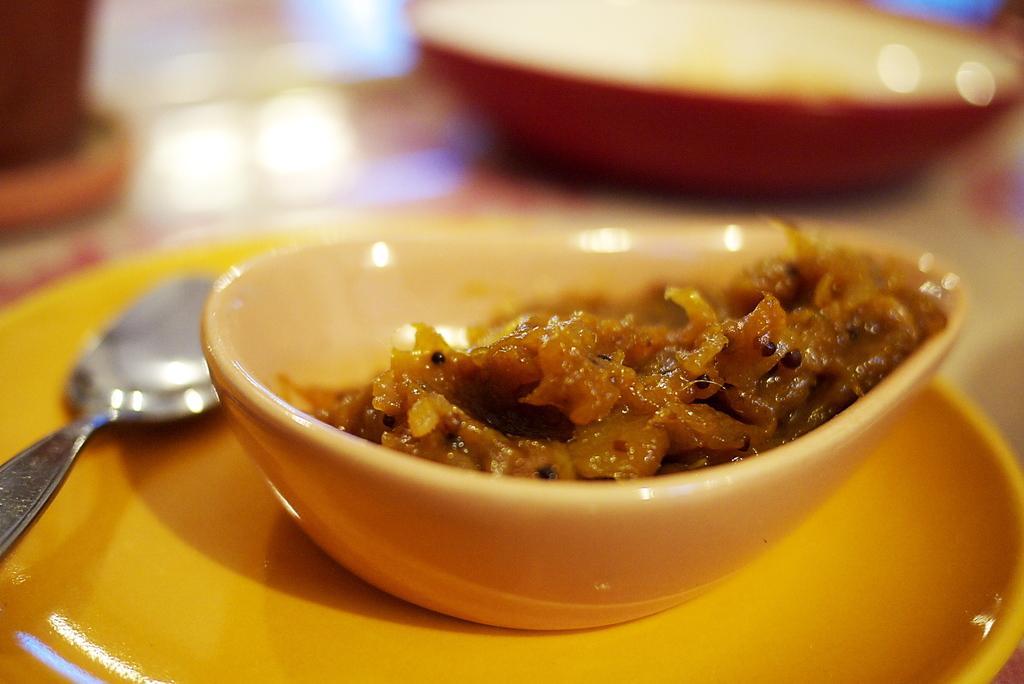How would you summarize this image in a sentence or two? In this picture I can see a plate and food in the bowl and I can see a spoon on the plate and it looks like a another bowl in the back. 